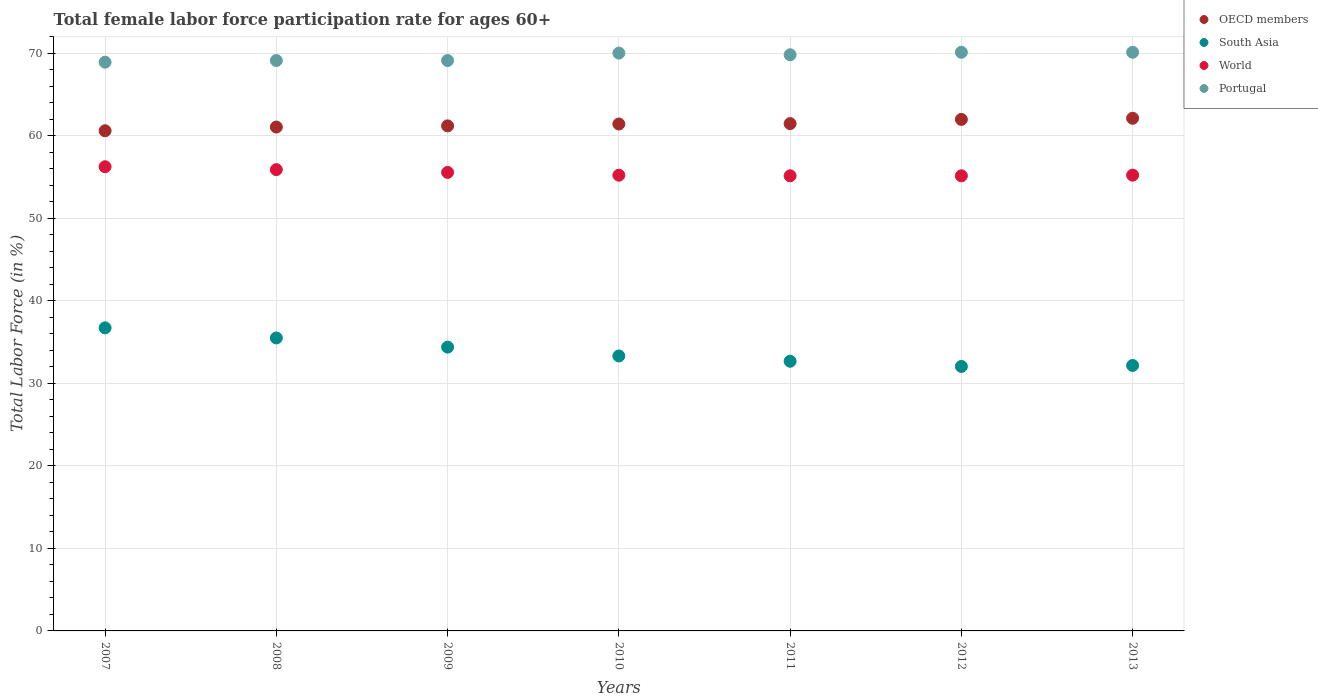Is the number of dotlines equal to the number of legend labels?
Your answer should be compact. Yes. What is the female labor force participation rate in World in 2009?
Provide a short and direct response. 55.55. Across all years, what is the maximum female labor force participation rate in South Asia?
Provide a short and direct response. 36.72. Across all years, what is the minimum female labor force participation rate in OECD members?
Ensure brevity in your answer.  60.59. In which year was the female labor force participation rate in Portugal minimum?
Offer a very short reply. 2007. What is the total female labor force participation rate in Portugal in the graph?
Keep it short and to the point. 487.1. What is the difference between the female labor force participation rate in Portugal in 2007 and that in 2011?
Provide a short and direct response. -0.9. What is the difference between the female labor force participation rate in World in 2010 and the female labor force participation rate in Portugal in 2012?
Make the answer very short. -14.89. What is the average female labor force participation rate in World per year?
Provide a short and direct response. 55.48. In the year 2008, what is the difference between the female labor force participation rate in World and female labor force participation rate in OECD members?
Provide a succinct answer. -5.16. What is the ratio of the female labor force participation rate in Portugal in 2007 to that in 2011?
Provide a succinct answer. 0.99. Is the difference between the female labor force participation rate in World in 2008 and 2012 greater than the difference between the female labor force participation rate in OECD members in 2008 and 2012?
Provide a short and direct response. Yes. What is the difference between the highest and the second highest female labor force participation rate in OECD members?
Your answer should be very brief. 0.14. What is the difference between the highest and the lowest female labor force participation rate in World?
Your response must be concise. 1.1. In how many years, is the female labor force participation rate in World greater than the average female labor force participation rate in World taken over all years?
Give a very brief answer. 3. Is it the case that in every year, the sum of the female labor force participation rate in South Asia and female labor force participation rate in OECD members  is greater than the sum of female labor force participation rate in Portugal and female labor force participation rate in World?
Provide a short and direct response. No. Does the female labor force participation rate in Portugal monotonically increase over the years?
Provide a succinct answer. No. Is the female labor force participation rate in Portugal strictly less than the female labor force participation rate in South Asia over the years?
Offer a terse response. No. How many dotlines are there?
Your response must be concise. 4. What is the difference between two consecutive major ticks on the Y-axis?
Provide a succinct answer. 10. Are the values on the major ticks of Y-axis written in scientific E-notation?
Make the answer very short. No. Does the graph contain any zero values?
Your answer should be compact. No. How are the legend labels stacked?
Provide a succinct answer. Vertical. What is the title of the graph?
Give a very brief answer. Total female labor force participation rate for ages 60+. Does "Armenia" appear as one of the legend labels in the graph?
Make the answer very short. No. What is the label or title of the Y-axis?
Provide a short and direct response. Total Labor Force (in %). What is the Total Labor Force (in %) in OECD members in 2007?
Make the answer very short. 60.59. What is the Total Labor Force (in %) of South Asia in 2007?
Offer a very short reply. 36.72. What is the Total Labor Force (in %) in World in 2007?
Ensure brevity in your answer.  56.23. What is the Total Labor Force (in %) of Portugal in 2007?
Keep it short and to the point. 68.9. What is the Total Labor Force (in %) of OECD members in 2008?
Your response must be concise. 61.04. What is the Total Labor Force (in %) in South Asia in 2008?
Keep it short and to the point. 35.49. What is the Total Labor Force (in %) of World in 2008?
Your answer should be very brief. 55.88. What is the Total Labor Force (in %) in Portugal in 2008?
Ensure brevity in your answer.  69.1. What is the Total Labor Force (in %) in OECD members in 2009?
Offer a terse response. 61.18. What is the Total Labor Force (in %) in South Asia in 2009?
Provide a succinct answer. 34.38. What is the Total Labor Force (in %) of World in 2009?
Make the answer very short. 55.55. What is the Total Labor Force (in %) in Portugal in 2009?
Your answer should be compact. 69.1. What is the Total Labor Force (in %) in OECD members in 2010?
Make the answer very short. 61.41. What is the Total Labor Force (in %) of South Asia in 2010?
Your response must be concise. 33.31. What is the Total Labor Force (in %) of World in 2010?
Provide a short and direct response. 55.21. What is the Total Labor Force (in %) of Portugal in 2010?
Your answer should be very brief. 70. What is the Total Labor Force (in %) of OECD members in 2011?
Make the answer very short. 61.46. What is the Total Labor Force (in %) of South Asia in 2011?
Keep it short and to the point. 32.67. What is the Total Labor Force (in %) in World in 2011?
Provide a succinct answer. 55.14. What is the Total Labor Force (in %) of Portugal in 2011?
Ensure brevity in your answer.  69.8. What is the Total Labor Force (in %) of OECD members in 2012?
Ensure brevity in your answer.  61.97. What is the Total Labor Force (in %) of South Asia in 2012?
Keep it short and to the point. 32.04. What is the Total Labor Force (in %) of World in 2012?
Provide a succinct answer. 55.14. What is the Total Labor Force (in %) in Portugal in 2012?
Your answer should be very brief. 70.1. What is the Total Labor Force (in %) of OECD members in 2013?
Your answer should be compact. 62.11. What is the Total Labor Force (in %) in South Asia in 2013?
Ensure brevity in your answer.  32.16. What is the Total Labor Force (in %) in World in 2013?
Your response must be concise. 55.21. What is the Total Labor Force (in %) of Portugal in 2013?
Give a very brief answer. 70.1. Across all years, what is the maximum Total Labor Force (in %) of OECD members?
Provide a short and direct response. 62.11. Across all years, what is the maximum Total Labor Force (in %) of South Asia?
Give a very brief answer. 36.72. Across all years, what is the maximum Total Labor Force (in %) in World?
Provide a succinct answer. 56.23. Across all years, what is the maximum Total Labor Force (in %) of Portugal?
Give a very brief answer. 70.1. Across all years, what is the minimum Total Labor Force (in %) of OECD members?
Ensure brevity in your answer.  60.59. Across all years, what is the minimum Total Labor Force (in %) in South Asia?
Offer a terse response. 32.04. Across all years, what is the minimum Total Labor Force (in %) of World?
Ensure brevity in your answer.  55.14. Across all years, what is the minimum Total Labor Force (in %) of Portugal?
Your response must be concise. 68.9. What is the total Total Labor Force (in %) of OECD members in the graph?
Ensure brevity in your answer.  429.76. What is the total Total Labor Force (in %) of South Asia in the graph?
Your answer should be very brief. 236.77. What is the total Total Labor Force (in %) of World in the graph?
Make the answer very short. 388.36. What is the total Total Labor Force (in %) of Portugal in the graph?
Your response must be concise. 487.1. What is the difference between the Total Labor Force (in %) of OECD members in 2007 and that in 2008?
Offer a very short reply. -0.45. What is the difference between the Total Labor Force (in %) in South Asia in 2007 and that in 2008?
Ensure brevity in your answer.  1.22. What is the difference between the Total Labor Force (in %) of World in 2007 and that in 2008?
Your response must be concise. 0.35. What is the difference between the Total Labor Force (in %) in OECD members in 2007 and that in 2009?
Keep it short and to the point. -0.59. What is the difference between the Total Labor Force (in %) of South Asia in 2007 and that in 2009?
Provide a short and direct response. 2.33. What is the difference between the Total Labor Force (in %) in World in 2007 and that in 2009?
Provide a succinct answer. 0.69. What is the difference between the Total Labor Force (in %) in OECD members in 2007 and that in 2010?
Your response must be concise. -0.82. What is the difference between the Total Labor Force (in %) in South Asia in 2007 and that in 2010?
Provide a short and direct response. 3.41. What is the difference between the Total Labor Force (in %) in World in 2007 and that in 2010?
Keep it short and to the point. 1.02. What is the difference between the Total Labor Force (in %) in Portugal in 2007 and that in 2010?
Give a very brief answer. -1.1. What is the difference between the Total Labor Force (in %) in OECD members in 2007 and that in 2011?
Ensure brevity in your answer.  -0.87. What is the difference between the Total Labor Force (in %) of South Asia in 2007 and that in 2011?
Give a very brief answer. 4.04. What is the difference between the Total Labor Force (in %) of World in 2007 and that in 2011?
Give a very brief answer. 1.1. What is the difference between the Total Labor Force (in %) in OECD members in 2007 and that in 2012?
Provide a short and direct response. -1.38. What is the difference between the Total Labor Force (in %) in South Asia in 2007 and that in 2012?
Your answer should be compact. 4.67. What is the difference between the Total Labor Force (in %) of World in 2007 and that in 2012?
Provide a succinct answer. 1.1. What is the difference between the Total Labor Force (in %) in OECD members in 2007 and that in 2013?
Your response must be concise. -1.51. What is the difference between the Total Labor Force (in %) in South Asia in 2007 and that in 2013?
Provide a short and direct response. 4.56. What is the difference between the Total Labor Force (in %) of World in 2007 and that in 2013?
Give a very brief answer. 1.02. What is the difference between the Total Labor Force (in %) in Portugal in 2007 and that in 2013?
Give a very brief answer. -1.2. What is the difference between the Total Labor Force (in %) in OECD members in 2008 and that in 2009?
Keep it short and to the point. -0.14. What is the difference between the Total Labor Force (in %) in South Asia in 2008 and that in 2009?
Keep it short and to the point. 1.11. What is the difference between the Total Labor Force (in %) in World in 2008 and that in 2009?
Ensure brevity in your answer.  0.34. What is the difference between the Total Labor Force (in %) in OECD members in 2008 and that in 2010?
Keep it short and to the point. -0.37. What is the difference between the Total Labor Force (in %) of South Asia in 2008 and that in 2010?
Provide a short and direct response. 2.18. What is the difference between the Total Labor Force (in %) in World in 2008 and that in 2010?
Offer a terse response. 0.67. What is the difference between the Total Labor Force (in %) of Portugal in 2008 and that in 2010?
Offer a terse response. -0.9. What is the difference between the Total Labor Force (in %) in OECD members in 2008 and that in 2011?
Your response must be concise. -0.42. What is the difference between the Total Labor Force (in %) in South Asia in 2008 and that in 2011?
Provide a succinct answer. 2.82. What is the difference between the Total Labor Force (in %) of World in 2008 and that in 2011?
Provide a short and direct response. 0.75. What is the difference between the Total Labor Force (in %) of OECD members in 2008 and that in 2012?
Give a very brief answer. -0.93. What is the difference between the Total Labor Force (in %) in South Asia in 2008 and that in 2012?
Provide a succinct answer. 3.45. What is the difference between the Total Labor Force (in %) in World in 2008 and that in 2012?
Your response must be concise. 0.75. What is the difference between the Total Labor Force (in %) in OECD members in 2008 and that in 2013?
Give a very brief answer. -1.06. What is the difference between the Total Labor Force (in %) of South Asia in 2008 and that in 2013?
Keep it short and to the point. 3.33. What is the difference between the Total Labor Force (in %) in World in 2008 and that in 2013?
Keep it short and to the point. 0.67. What is the difference between the Total Labor Force (in %) of OECD members in 2009 and that in 2010?
Provide a short and direct response. -0.23. What is the difference between the Total Labor Force (in %) in South Asia in 2009 and that in 2010?
Offer a very short reply. 1.07. What is the difference between the Total Labor Force (in %) of World in 2009 and that in 2010?
Ensure brevity in your answer.  0.34. What is the difference between the Total Labor Force (in %) in OECD members in 2009 and that in 2011?
Offer a very short reply. -0.27. What is the difference between the Total Labor Force (in %) of South Asia in 2009 and that in 2011?
Offer a terse response. 1.71. What is the difference between the Total Labor Force (in %) in World in 2009 and that in 2011?
Provide a succinct answer. 0.41. What is the difference between the Total Labor Force (in %) of Portugal in 2009 and that in 2011?
Offer a very short reply. -0.7. What is the difference between the Total Labor Force (in %) in OECD members in 2009 and that in 2012?
Your answer should be very brief. -0.78. What is the difference between the Total Labor Force (in %) of South Asia in 2009 and that in 2012?
Provide a succinct answer. 2.34. What is the difference between the Total Labor Force (in %) of World in 2009 and that in 2012?
Make the answer very short. 0.41. What is the difference between the Total Labor Force (in %) in Portugal in 2009 and that in 2012?
Offer a very short reply. -1. What is the difference between the Total Labor Force (in %) in OECD members in 2009 and that in 2013?
Your answer should be compact. -0.92. What is the difference between the Total Labor Force (in %) in South Asia in 2009 and that in 2013?
Make the answer very short. 2.22. What is the difference between the Total Labor Force (in %) of World in 2009 and that in 2013?
Offer a very short reply. 0.33. What is the difference between the Total Labor Force (in %) of Portugal in 2009 and that in 2013?
Ensure brevity in your answer.  -1. What is the difference between the Total Labor Force (in %) of OECD members in 2010 and that in 2011?
Your answer should be very brief. -0.05. What is the difference between the Total Labor Force (in %) in South Asia in 2010 and that in 2011?
Make the answer very short. 0.64. What is the difference between the Total Labor Force (in %) of World in 2010 and that in 2011?
Provide a short and direct response. 0.07. What is the difference between the Total Labor Force (in %) of Portugal in 2010 and that in 2011?
Keep it short and to the point. 0.2. What is the difference between the Total Labor Force (in %) of OECD members in 2010 and that in 2012?
Your answer should be very brief. -0.56. What is the difference between the Total Labor Force (in %) of South Asia in 2010 and that in 2012?
Your response must be concise. 1.27. What is the difference between the Total Labor Force (in %) of World in 2010 and that in 2012?
Offer a terse response. 0.07. What is the difference between the Total Labor Force (in %) in OECD members in 2010 and that in 2013?
Make the answer very short. -0.7. What is the difference between the Total Labor Force (in %) in South Asia in 2010 and that in 2013?
Give a very brief answer. 1.15. What is the difference between the Total Labor Force (in %) in World in 2010 and that in 2013?
Give a very brief answer. -0. What is the difference between the Total Labor Force (in %) of Portugal in 2010 and that in 2013?
Make the answer very short. -0.1. What is the difference between the Total Labor Force (in %) in OECD members in 2011 and that in 2012?
Make the answer very short. -0.51. What is the difference between the Total Labor Force (in %) of South Asia in 2011 and that in 2012?
Provide a succinct answer. 0.63. What is the difference between the Total Labor Force (in %) of World in 2011 and that in 2012?
Give a very brief answer. 0. What is the difference between the Total Labor Force (in %) in OECD members in 2011 and that in 2013?
Offer a terse response. -0.65. What is the difference between the Total Labor Force (in %) of South Asia in 2011 and that in 2013?
Make the answer very short. 0.51. What is the difference between the Total Labor Force (in %) in World in 2011 and that in 2013?
Offer a very short reply. -0.08. What is the difference between the Total Labor Force (in %) of OECD members in 2012 and that in 2013?
Offer a very short reply. -0.14. What is the difference between the Total Labor Force (in %) in South Asia in 2012 and that in 2013?
Your answer should be very brief. -0.12. What is the difference between the Total Labor Force (in %) of World in 2012 and that in 2013?
Provide a succinct answer. -0.08. What is the difference between the Total Labor Force (in %) of Portugal in 2012 and that in 2013?
Keep it short and to the point. 0. What is the difference between the Total Labor Force (in %) in OECD members in 2007 and the Total Labor Force (in %) in South Asia in 2008?
Your answer should be very brief. 25.1. What is the difference between the Total Labor Force (in %) of OECD members in 2007 and the Total Labor Force (in %) of World in 2008?
Your answer should be very brief. 4.71. What is the difference between the Total Labor Force (in %) of OECD members in 2007 and the Total Labor Force (in %) of Portugal in 2008?
Provide a succinct answer. -8.51. What is the difference between the Total Labor Force (in %) of South Asia in 2007 and the Total Labor Force (in %) of World in 2008?
Keep it short and to the point. -19.17. What is the difference between the Total Labor Force (in %) of South Asia in 2007 and the Total Labor Force (in %) of Portugal in 2008?
Offer a terse response. -32.38. What is the difference between the Total Labor Force (in %) of World in 2007 and the Total Labor Force (in %) of Portugal in 2008?
Ensure brevity in your answer.  -12.87. What is the difference between the Total Labor Force (in %) of OECD members in 2007 and the Total Labor Force (in %) of South Asia in 2009?
Keep it short and to the point. 26.21. What is the difference between the Total Labor Force (in %) in OECD members in 2007 and the Total Labor Force (in %) in World in 2009?
Offer a terse response. 5.05. What is the difference between the Total Labor Force (in %) of OECD members in 2007 and the Total Labor Force (in %) of Portugal in 2009?
Ensure brevity in your answer.  -8.51. What is the difference between the Total Labor Force (in %) of South Asia in 2007 and the Total Labor Force (in %) of World in 2009?
Provide a succinct answer. -18.83. What is the difference between the Total Labor Force (in %) in South Asia in 2007 and the Total Labor Force (in %) in Portugal in 2009?
Your answer should be very brief. -32.38. What is the difference between the Total Labor Force (in %) in World in 2007 and the Total Labor Force (in %) in Portugal in 2009?
Your response must be concise. -12.87. What is the difference between the Total Labor Force (in %) of OECD members in 2007 and the Total Labor Force (in %) of South Asia in 2010?
Keep it short and to the point. 27.28. What is the difference between the Total Labor Force (in %) in OECD members in 2007 and the Total Labor Force (in %) in World in 2010?
Provide a short and direct response. 5.38. What is the difference between the Total Labor Force (in %) of OECD members in 2007 and the Total Labor Force (in %) of Portugal in 2010?
Provide a succinct answer. -9.41. What is the difference between the Total Labor Force (in %) in South Asia in 2007 and the Total Labor Force (in %) in World in 2010?
Offer a terse response. -18.49. What is the difference between the Total Labor Force (in %) of South Asia in 2007 and the Total Labor Force (in %) of Portugal in 2010?
Offer a very short reply. -33.28. What is the difference between the Total Labor Force (in %) of World in 2007 and the Total Labor Force (in %) of Portugal in 2010?
Provide a succinct answer. -13.77. What is the difference between the Total Labor Force (in %) of OECD members in 2007 and the Total Labor Force (in %) of South Asia in 2011?
Offer a terse response. 27.92. What is the difference between the Total Labor Force (in %) of OECD members in 2007 and the Total Labor Force (in %) of World in 2011?
Your answer should be very brief. 5.46. What is the difference between the Total Labor Force (in %) of OECD members in 2007 and the Total Labor Force (in %) of Portugal in 2011?
Keep it short and to the point. -9.21. What is the difference between the Total Labor Force (in %) of South Asia in 2007 and the Total Labor Force (in %) of World in 2011?
Give a very brief answer. -18.42. What is the difference between the Total Labor Force (in %) of South Asia in 2007 and the Total Labor Force (in %) of Portugal in 2011?
Your answer should be very brief. -33.08. What is the difference between the Total Labor Force (in %) of World in 2007 and the Total Labor Force (in %) of Portugal in 2011?
Keep it short and to the point. -13.57. What is the difference between the Total Labor Force (in %) of OECD members in 2007 and the Total Labor Force (in %) of South Asia in 2012?
Provide a succinct answer. 28.55. What is the difference between the Total Labor Force (in %) of OECD members in 2007 and the Total Labor Force (in %) of World in 2012?
Ensure brevity in your answer.  5.46. What is the difference between the Total Labor Force (in %) of OECD members in 2007 and the Total Labor Force (in %) of Portugal in 2012?
Make the answer very short. -9.51. What is the difference between the Total Labor Force (in %) of South Asia in 2007 and the Total Labor Force (in %) of World in 2012?
Your response must be concise. -18.42. What is the difference between the Total Labor Force (in %) of South Asia in 2007 and the Total Labor Force (in %) of Portugal in 2012?
Your answer should be compact. -33.38. What is the difference between the Total Labor Force (in %) of World in 2007 and the Total Labor Force (in %) of Portugal in 2012?
Give a very brief answer. -13.87. What is the difference between the Total Labor Force (in %) in OECD members in 2007 and the Total Labor Force (in %) in South Asia in 2013?
Your response must be concise. 28.43. What is the difference between the Total Labor Force (in %) of OECD members in 2007 and the Total Labor Force (in %) of World in 2013?
Provide a succinct answer. 5.38. What is the difference between the Total Labor Force (in %) of OECD members in 2007 and the Total Labor Force (in %) of Portugal in 2013?
Make the answer very short. -9.51. What is the difference between the Total Labor Force (in %) of South Asia in 2007 and the Total Labor Force (in %) of World in 2013?
Your answer should be very brief. -18.5. What is the difference between the Total Labor Force (in %) in South Asia in 2007 and the Total Labor Force (in %) in Portugal in 2013?
Provide a succinct answer. -33.38. What is the difference between the Total Labor Force (in %) in World in 2007 and the Total Labor Force (in %) in Portugal in 2013?
Give a very brief answer. -13.87. What is the difference between the Total Labor Force (in %) in OECD members in 2008 and the Total Labor Force (in %) in South Asia in 2009?
Provide a short and direct response. 26.66. What is the difference between the Total Labor Force (in %) in OECD members in 2008 and the Total Labor Force (in %) in World in 2009?
Provide a succinct answer. 5.49. What is the difference between the Total Labor Force (in %) in OECD members in 2008 and the Total Labor Force (in %) in Portugal in 2009?
Make the answer very short. -8.06. What is the difference between the Total Labor Force (in %) of South Asia in 2008 and the Total Labor Force (in %) of World in 2009?
Your answer should be very brief. -20.06. What is the difference between the Total Labor Force (in %) of South Asia in 2008 and the Total Labor Force (in %) of Portugal in 2009?
Make the answer very short. -33.61. What is the difference between the Total Labor Force (in %) of World in 2008 and the Total Labor Force (in %) of Portugal in 2009?
Your response must be concise. -13.22. What is the difference between the Total Labor Force (in %) in OECD members in 2008 and the Total Labor Force (in %) in South Asia in 2010?
Keep it short and to the point. 27.73. What is the difference between the Total Labor Force (in %) of OECD members in 2008 and the Total Labor Force (in %) of World in 2010?
Keep it short and to the point. 5.83. What is the difference between the Total Labor Force (in %) of OECD members in 2008 and the Total Labor Force (in %) of Portugal in 2010?
Offer a terse response. -8.96. What is the difference between the Total Labor Force (in %) of South Asia in 2008 and the Total Labor Force (in %) of World in 2010?
Provide a succinct answer. -19.72. What is the difference between the Total Labor Force (in %) of South Asia in 2008 and the Total Labor Force (in %) of Portugal in 2010?
Provide a short and direct response. -34.51. What is the difference between the Total Labor Force (in %) in World in 2008 and the Total Labor Force (in %) in Portugal in 2010?
Ensure brevity in your answer.  -14.12. What is the difference between the Total Labor Force (in %) of OECD members in 2008 and the Total Labor Force (in %) of South Asia in 2011?
Offer a terse response. 28.37. What is the difference between the Total Labor Force (in %) of OECD members in 2008 and the Total Labor Force (in %) of World in 2011?
Your response must be concise. 5.91. What is the difference between the Total Labor Force (in %) of OECD members in 2008 and the Total Labor Force (in %) of Portugal in 2011?
Keep it short and to the point. -8.76. What is the difference between the Total Labor Force (in %) in South Asia in 2008 and the Total Labor Force (in %) in World in 2011?
Give a very brief answer. -19.64. What is the difference between the Total Labor Force (in %) in South Asia in 2008 and the Total Labor Force (in %) in Portugal in 2011?
Give a very brief answer. -34.31. What is the difference between the Total Labor Force (in %) of World in 2008 and the Total Labor Force (in %) of Portugal in 2011?
Provide a short and direct response. -13.92. What is the difference between the Total Labor Force (in %) in OECD members in 2008 and the Total Labor Force (in %) in South Asia in 2012?
Your answer should be compact. 29. What is the difference between the Total Labor Force (in %) of OECD members in 2008 and the Total Labor Force (in %) of World in 2012?
Keep it short and to the point. 5.91. What is the difference between the Total Labor Force (in %) in OECD members in 2008 and the Total Labor Force (in %) in Portugal in 2012?
Make the answer very short. -9.06. What is the difference between the Total Labor Force (in %) in South Asia in 2008 and the Total Labor Force (in %) in World in 2012?
Your answer should be very brief. -19.64. What is the difference between the Total Labor Force (in %) of South Asia in 2008 and the Total Labor Force (in %) of Portugal in 2012?
Offer a terse response. -34.61. What is the difference between the Total Labor Force (in %) of World in 2008 and the Total Labor Force (in %) of Portugal in 2012?
Offer a terse response. -14.22. What is the difference between the Total Labor Force (in %) in OECD members in 2008 and the Total Labor Force (in %) in South Asia in 2013?
Keep it short and to the point. 28.88. What is the difference between the Total Labor Force (in %) in OECD members in 2008 and the Total Labor Force (in %) in World in 2013?
Your response must be concise. 5.83. What is the difference between the Total Labor Force (in %) of OECD members in 2008 and the Total Labor Force (in %) of Portugal in 2013?
Ensure brevity in your answer.  -9.06. What is the difference between the Total Labor Force (in %) of South Asia in 2008 and the Total Labor Force (in %) of World in 2013?
Give a very brief answer. -19.72. What is the difference between the Total Labor Force (in %) in South Asia in 2008 and the Total Labor Force (in %) in Portugal in 2013?
Provide a short and direct response. -34.61. What is the difference between the Total Labor Force (in %) of World in 2008 and the Total Labor Force (in %) of Portugal in 2013?
Offer a terse response. -14.22. What is the difference between the Total Labor Force (in %) of OECD members in 2009 and the Total Labor Force (in %) of South Asia in 2010?
Provide a short and direct response. 27.87. What is the difference between the Total Labor Force (in %) of OECD members in 2009 and the Total Labor Force (in %) of World in 2010?
Provide a succinct answer. 5.97. What is the difference between the Total Labor Force (in %) of OECD members in 2009 and the Total Labor Force (in %) of Portugal in 2010?
Give a very brief answer. -8.82. What is the difference between the Total Labor Force (in %) of South Asia in 2009 and the Total Labor Force (in %) of World in 2010?
Your answer should be compact. -20.83. What is the difference between the Total Labor Force (in %) in South Asia in 2009 and the Total Labor Force (in %) in Portugal in 2010?
Keep it short and to the point. -35.62. What is the difference between the Total Labor Force (in %) in World in 2009 and the Total Labor Force (in %) in Portugal in 2010?
Give a very brief answer. -14.45. What is the difference between the Total Labor Force (in %) in OECD members in 2009 and the Total Labor Force (in %) in South Asia in 2011?
Offer a terse response. 28.51. What is the difference between the Total Labor Force (in %) of OECD members in 2009 and the Total Labor Force (in %) of World in 2011?
Your response must be concise. 6.05. What is the difference between the Total Labor Force (in %) of OECD members in 2009 and the Total Labor Force (in %) of Portugal in 2011?
Ensure brevity in your answer.  -8.62. What is the difference between the Total Labor Force (in %) in South Asia in 2009 and the Total Labor Force (in %) in World in 2011?
Offer a terse response. -20.75. What is the difference between the Total Labor Force (in %) of South Asia in 2009 and the Total Labor Force (in %) of Portugal in 2011?
Keep it short and to the point. -35.42. What is the difference between the Total Labor Force (in %) of World in 2009 and the Total Labor Force (in %) of Portugal in 2011?
Provide a succinct answer. -14.25. What is the difference between the Total Labor Force (in %) of OECD members in 2009 and the Total Labor Force (in %) of South Asia in 2012?
Offer a terse response. 29.14. What is the difference between the Total Labor Force (in %) of OECD members in 2009 and the Total Labor Force (in %) of World in 2012?
Offer a very short reply. 6.05. What is the difference between the Total Labor Force (in %) in OECD members in 2009 and the Total Labor Force (in %) in Portugal in 2012?
Offer a terse response. -8.92. What is the difference between the Total Labor Force (in %) of South Asia in 2009 and the Total Labor Force (in %) of World in 2012?
Ensure brevity in your answer.  -20.75. What is the difference between the Total Labor Force (in %) of South Asia in 2009 and the Total Labor Force (in %) of Portugal in 2012?
Provide a short and direct response. -35.72. What is the difference between the Total Labor Force (in %) of World in 2009 and the Total Labor Force (in %) of Portugal in 2012?
Your response must be concise. -14.55. What is the difference between the Total Labor Force (in %) of OECD members in 2009 and the Total Labor Force (in %) of South Asia in 2013?
Offer a terse response. 29.02. What is the difference between the Total Labor Force (in %) of OECD members in 2009 and the Total Labor Force (in %) of World in 2013?
Give a very brief answer. 5.97. What is the difference between the Total Labor Force (in %) in OECD members in 2009 and the Total Labor Force (in %) in Portugal in 2013?
Your response must be concise. -8.92. What is the difference between the Total Labor Force (in %) in South Asia in 2009 and the Total Labor Force (in %) in World in 2013?
Provide a short and direct response. -20.83. What is the difference between the Total Labor Force (in %) in South Asia in 2009 and the Total Labor Force (in %) in Portugal in 2013?
Provide a short and direct response. -35.72. What is the difference between the Total Labor Force (in %) in World in 2009 and the Total Labor Force (in %) in Portugal in 2013?
Offer a terse response. -14.55. What is the difference between the Total Labor Force (in %) of OECD members in 2010 and the Total Labor Force (in %) of South Asia in 2011?
Provide a succinct answer. 28.74. What is the difference between the Total Labor Force (in %) in OECD members in 2010 and the Total Labor Force (in %) in World in 2011?
Your answer should be very brief. 6.27. What is the difference between the Total Labor Force (in %) in OECD members in 2010 and the Total Labor Force (in %) in Portugal in 2011?
Offer a very short reply. -8.39. What is the difference between the Total Labor Force (in %) of South Asia in 2010 and the Total Labor Force (in %) of World in 2011?
Offer a very short reply. -21.83. What is the difference between the Total Labor Force (in %) in South Asia in 2010 and the Total Labor Force (in %) in Portugal in 2011?
Your response must be concise. -36.49. What is the difference between the Total Labor Force (in %) in World in 2010 and the Total Labor Force (in %) in Portugal in 2011?
Offer a terse response. -14.59. What is the difference between the Total Labor Force (in %) of OECD members in 2010 and the Total Labor Force (in %) of South Asia in 2012?
Keep it short and to the point. 29.37. What is the difference between the Total Labor Force (in %) of OECD members in 2010 and the Total Labor Force (in %) of World in 2012?
Provide a succinct answer. 6.28. What is the difference between the Total Labor Force (in %) in OECD members in 2010 and the Total Labor Force (in %) in Portugal in 2012?
Provide a short and direct response. -8.69. What is the difference between the Total Labor Force (in %) of South Asia in 2010 and the Total Labor Force (in %) of World in 2012?
Give a very brief answer. -21.83. What is the difference between the Total Labor Force (in %) in South Asia in 2010 and the Total Labor Force (in %) in Portugal in 2012?
Offer a very short reply. -36.79. What is the difference between the Total Labor Force (in %) in World in 2010 and the Total Labor Force (in %) in Portugal in 2012?
Make the answer very short. -14.89. What is the difference between the Total Labor Force (in %) of OECD members in 2010 and the Total Labor Force (in %) of South Asia in 2013?
Make the answer very short. 29.25. What is the difference between the Total Labor Force (in %) in OECD members in 2010 and the Total Labor Force (in %) in World in 2013?
Keep it short and to the point. 6.2. What is the difference between the Total Labor Force (in %) in OECD members in 2010 and the Total Labor Force (in %) in Portugal in 2013?
Give a very brief answer. -8.69. What is the difference between the Total Labor Force (in %) in South Asia in 2010 and the Total Labor Force (in %) in World in 2013?
Offer a terse response. -21.91. What is the difference between the Total Labor Force (in %) of South Asia in 2010 and the Total Labor Force (in %) of Portugal in 2013?
Your answer should be compact. -36.79. What is the difference between the Total Labor Force (in %) of World in 2010 and the Total Labor Force (in %) of Portugal in 2013?
Your answer should be compact. -14.89. What is the difference between the Total Labor Force (in %) in OECD members in 2011 and the Total Labor Force (in %) in South Asia in 2012?
Make the answer very short. 29.42. What is the difference between the Total Labor Force (in %) in OECD members in 2011 and the Total Labor Force (in %) in World in 2012?
Make the answer very short. 6.32. What is the difference between the Total Labor Force (in %) of OECD members in 2011 and the Total Labor Force (in %) of Portugal in 2012?
Offer a very short reply. -8.64. What is the difference between the Total Labor Force (in %) of South Asia in 2011 and the Total Labor Force (in %) of World in 2012?
Make the answer very short. -22.46. What is the difference between the Total Labor Force (in %) in South Asia in 2011 and the Total Labor Force (in %) in Portugal in 2012?
Ensure brevity in your answer.  -37.43. What is the difference between the Total Labor Force (in %) in World in 2011 and the Total Labor Force (in %) in Portugal in 2012?
Your response must be concise. -14.96. What is the difference between the Total Labor Force (in %) of OECD members in 2011 and the Total Labor Force (in %) of South Asia in 2013?
Make the answer very short. 29.3. What is the difference between the Total Labor Force (in %) in OECD members in 2011 and the Total Labor Force (in %) in World in 2013?
Offer a very short reply. 6.24. What is the difference between the Total Labor Force (in %) of OECD members in 2011 and the Total Labor Force (in %) of Portugal in 2013?
Give a very brief answer. -8.64. What is the difference between the Total Labor Force (in %) in South Asia in 2011 and the Total Labor Force (in %) in World in 2013?
Make the answer very short. -22.54. What is the difference between the Total Labor Force (in %) in South Asia in 2011 and the Total Labor Force (in %) in Portugal in 2013?
Keep it short and to the point. -37.43. What is the difference between the Total Labor Force (in %) of World in 2011 and the Total Labor Force (in %) of Portugal in 2013?
Offer a terse response. -14.96. What is the difference between the Total Labor Force (in %) of OECD members in 2012 and the Total Labor Force (in %) of South Asia in 2013?
Offer a very short reply. 29.81. What is the difference between the Total Labor Force (in %) of OECD members in 2012 and the Total Labor Force (in %) of World in 2013?
Ensure brevity in your answer.  6.75. What is the difference between the Total Labor Force (in %) of OECD members in 2012 and the Total Labor Force (in %) of Portugal in 2013?
Offer a terse response. -8.13. What is the difference between the Total Labor Force (in %) of South Asia in 2012 and the Total Labor Force (in %) of World in 2013?
Give a very brief answer. -23.17. What is the difference between the Total Labor Force (in %) of South Asia in 2012 and the Total Labor Force (in %) of Portugal in 2013?
Your response must be concise. -38.06. What is the difference between the Total Labor Force (in %) of World in 2012 and the Total Labor Force (in %) of Portugal in 2013?
Provide a short and direct response. -14.96. What is the average Total Labor Force (in %) in OECD members per year?
Ensure brevity in your answer.  61.39. What is the average Total Labor Force (in %) of South Asia per year?
Ensure brevity in your answer.  33.82. What is the average Total Labor Force (in %) of World per year?
Make the answer very short. 55.48. What is the average Total Labor Force (in %) in Portugal per year?
Offer a very short reply. 69.59. In the year 2007, what is the difference between the Total Labor Force (in %) of OECD members and Total Labor Force (in %) of South Asia?
Give a very brief answer. 23.88. In the year 2007, what is the difference between the Total Labor Force (in %) of OECD members and Total Labor Force (in %) of World?
Give a very brief answer. 4.36. In the year 2007, what is the difference between the Total Labor Force (in %) of OECD members and Total Labor Force (in %) of Portugal?
Give a very brief answer. -8.31. In the year 2007, what is the difference between the Total Labor Force (in %) of South Asia and Total Labor Force (in %) of World?
Offer a terse response. -19.52. In the year 2007, what is the difference between the Total Labor Force (in %) of South Asia and Total Labor Force (in %) of Portugal?
Make the answer very short. -32.18. In the year 2007, what is the difference between the Total Labor Force (in %) in World and Total Labor Force (in %) in Portugal?
Offer a very short reply. -12.67. In the year 2008, what is the difference between the Total Labor Force (in %) of OECD members and Total Labor Force (in %) of South Asia?
Give a very brief answer. 25.55. In the year 2008, what is the difference between the Total Labor Force (in %) in OECD members and Total Labor Force (in %) in World?
Ensure brevity in your answer.  5.16. In the year 2008, what is the difference between the Total Labor Force (in %) of OECD members and Total Labor Force (in %) of Portugal?
Offer a terse response. -8.06. In the year 2008, what is the difference between the Total Labor Force (in %) in South Asia and Total Labor Force (in %) in World?
Your answer should be very brief. -20.39. In the year 2008, what is the difference between the Total Labor Force (in %) of South Asia and Total Labor Force (in %) of Portugal?
Offer a terse response. -33.61. In the year 2008, what is the difference between the Total Labor Force (in %) in World and Total Labor Force (in %) in Portugal?
Offer a terse response. -13.22. In the year 2009, what is the difference between the Total Labor Force (in %) of OECD members and Total Labor Force (in %) of South Asia?
Provide a short and direct response. 26.8. In the year 2009, what is the difference between the Total Labor Force (in %) of OECD members and Total Labor Force (in %) of World?
Give a very brief answer. 5.64. In the year 2009, what is the difference between the Total Labor Force (in %) in OECD members and Total Labor Force (in %) in Portugal?
Offer a terse response. -7.92. In the year 2009, what is the difference between the Total Labor Force (in %) of South Asia and Total Labor Force (in %) of World?
Your answer should be compact. -21.16. In the year 2009, what is the difference between the Total Labor Force (in %) in South Asia and Total Labor Force (in %) in Portugal?
Your response must be concise. -34.72. In the year 2009, what is the difference between the Total Labor Force (in %) of World and Total Labor Force (in %) of Portugal?
Provide a short and direct response. -13.55. In the year 2010, what is the difference between the Total Labor Force (in %) in OECD members and Total Labor Force (in %) in South Asia?
Ensure brevity in your answer.  28.1. In the year 2010, what is the difference between the Total Labor Force (in %) in OECD members and Total Labor Force (in %) in World?
Your answer should be compact. 6.2. In the year 2010, what is the difference between the Total Labor Force (in %) of OECD members and Total Labor Force (in %) of Portugal?
Your answer should be very brief. -8.59. In the year 2010, what is the difference between the Total Labor Force (in %) of South Asia and Total Labor Force (in %) of World?
Your response must be concise. -21.9. In the year 2010, what is the difference between the Total Labor Force (in %) of South Asia and Total Labor Force (in %) of Portugal?
Keep it short and to the point. -36.69. In the year 2010, what is the difference between the Total Labor Force (in %) in World and Total Labor Force (in %) in Portugal?
Provide a succinct answer. -14.79. In the year 2011, what is the difference between the Total Labor Force (in %) in OECD members and Total Labor Force (in %) in South Asia?
Give a very brief answer. 28.79. In the year 2011, what is the difference between the Total Labor Force (in %) in OECD members and Total Labor Force (in %) in World?
Make the answer very short. 6.32. In the year 2011, what is the difference between the Total Labor Force (in %) in OECD members and Total Labor Force (in %) in Portugal?
Your answer should be very brief. -8.34. In the year 2011, what is the difference between the Total Labor Force (in %) in South Asia and Total Labor Force (in %) in World?
Provide a short and direct response. -22.46. In the year 2011, what is the difference between the Total Labor Force (in %) of South Asia and Total Labor Force (in %) of Portugal?
Give a very brief answer. -37.13. In the year 2011, what is the difference between the Total Labor Force (in %) in World and Total Labor Force (in %) in Portugal?
Your response must be concise. -14.66. In the year 2012, what is the difference between the Total Labor Force (in %) of OECD members and Total Labor Force (in %) of South Asia?
Keep it short and to the point. 29.93. In the year 2012, what is the difference between the Total Labor Force (in %) of OECD members and Total Labor Force (in %) of World?
Your answer should be compact. 6.83. In the year 2012, what is the difference between the Total Labor Force (in %) of OECD members and Total Labor Force (in %) of Portugal?
Provide a succinct answer. -8.13. In the year 2012, what is the difference between the Total Labor Force (in %) in South Asia and Total Labor Force (in %) in World?
Offer a terse response. -23.09. In the year 2012, what is the difference between the Total Labor Force (in %) in South Asia and Total Labor Force (in %) in Portugal?
Provide a succinct answer. -38.06. In the year 2012, what is the difference between the Total Labor Force (in %) in World and Total Labor Force (in %) in Portugal?
Your response must be concise. -14.96. In the year 2013, what is the difference between the Total Labor Force (in %) in OECD members and Total Labor Force (in %) in South Asia?
Provide a short and direct response. 29.95. In the year 2013, what is the difference between the Total Labor Force (in %) of OECD members and Total Labor Force (in %) of World?
Your response must be concise. 6.89. In the year 2013, what is the difference between the Total Labor Force (in %) in OECD members and Total Labor Force (in %) in Portugal?
Offer a very short reply. -7.99. In the year 2013, what is the difference between the Total Labor Force (in %) in South Asia and Total Labor Force (in %) in World?
Keep it short and to the point. -23.05. In the year 2013, what is the difference between the Total Labor Force (in %) in South Asia and Total Labor Force (in %) in Portugal?
Offer a very short reply. -37.94. In the year 2013, what is the difference between the Total Labor Force (in %) in World and Total Labor Force (in %) in Portugal?
Offer a terse response. -14.89. What is the ratio of the Total Labor Force (in %) of South Asia in 2007 to that in 2008?
Offer a very short reply. 1.03. What is the ratio of the Total Labor Force (in %) of World in 2007 to that in 2008?
Provide a short and direct response. 1.01. What is the ratio of the Total Labor Force (in %) of Portugal in 2007 to that in 2008?
Offer a terse response. 1. What is the ratio of the Total Labor Force (in %) of OECD members in 2007 to that in 2009?
Offer a very short reply. 0.99. What is the ratio of the Total Labor Force (in %) of South Asia in 2007 to that in 2009?
Your answer should be very brief. 1.07. What is the ratio of the Total Labor Force (in %) in World in 2007 to that in 2009?
Your answer should be compact. 1.01. What is the ratio of the Total Labor Force (in %) of Portugal in 2007 to that in 2009?
Keep it short and to the point. 1. What is the ratio of the Total Labor Force (in %) in OECD members in 2007 to that in 2010?
Give a very brief answer. 0.99. What is the ratio of the Total Labor Force (in %) of South Asia in 2007 to that in 2010?
Your answer should be very brief. 1.1. What is the ratio of the Total Labor Force (in %) in World in 2007 to that in 2010?
Offer a terse response. 1.02. What is the ratio of the Total Labor Force (in %) of Portugal in 2007 to that in 2010?
Provide a succinct answer. 0.98. What is the ratio of the Total Labor Force (in %) of OECD members in 2007 to that in 2011?
Your response must be concise. 0.99. What is the ratio of the Total Labor Force (in %) in South Asia in 2007 to that in 2011?
Provide a short and direct response. 1.12. What is the ratio of the Total Labor Force (in %) of World in 2007 to that in 2011?
Offer a very short reply. 1.02. What is the ratio of the Total Labor Force (in %) of Portugal in 2007 to that in 2011?
Provide a succinct answer. 0.99. What is the ratio of the Total Labor Force (in %) in OECD members in 2007 to that in 2012?
Offer a very short reply. 0.98. What is the ratio of the Total Labor Force (in %) in South Asia in 2007 to that in 2012?
Make the answer very short. 1.15. What is the ratio of the Total Labor Force (in %) in World in 2007 to that in 2012?
Ensure brevity in your answer.  1.02. What is the ratio of the Total Labor Force (in %) of Portugal in 2007 to that in 2012?
Give a very brief answer. 0.98. What is the ratio of the Total Labor Force (in %) in OECD members in 2007 to that in 2013?
Your answer should be compact. 0.98. What is the ratio of the Total Labor Force (in %) of South Asia in 2007 to that in 2013?
Provide a succinct answer. 1.14. What is the ratio of the Total Labor Force (in %) in World in 2007 to that in 2013?
Provide a short and direct response. 1.02. What is the ratio of the Total Labor Force (in %) in Portugal in 2007 to that in 2013?
Ensure brevity in your answer.  0.98. What is the ratio of the Total Labor Force (in %) of OECD members in 2008 to that in 2009?
Keep it short and to the point. 1. What is the ratio of the Total Labor Force (in %) in South Asia in 2008 to that in 2009?
Give a very brief answer. 1.03. What is the ratio of the Total Labor Force (in %) of Portugal in 2008 to that in 2009?
Your answer should be very brief. 1. What is the ratio of the Total Labor Force (in %) of OECD members in 2008 to that in 2010?
Provide a succinct answer. 0.99. What is the ratio of the Total Labor Force (in %) of South Asia in 2008 to that in 2010?
Keep it short and to the point. 1.07. What is the ratio of the Total Labor Force (in %) in World in 2008 to that in 2010?
Your answer should be compact. 1.01. What is the ratio of the Total Labor Force (in %) in Portugal in 2008 to that in 2010?
Provide a short and direct response. 0.99. What is the ratio of the Total Labor Force (in %) in South Asia in 2008 to that in 2011?
Keep it short and to the point. 1.09. What is the ratio of the Total Labor Force (in %) in World in 2008 to that in 2011?
Provide a succinct answer. 1.01. What is the ratio of the Total Labor Force (in %) of OECD members in 2008 to that in 2012?
Offer a very short reply. 0.99. What is the ratio of the Total Labor Force (in %) of South Asia in 2008 to that in 2012?
Make the answer very short. 1.11. What is the ratio of the Total Labor Force (in %) in World in 2008 to that in 2012?
Give a very brief answer. 1.01. What is the ratio of the Total Labor Force (in %) in Portugal in 2008 to that in 2012?
Give a very brief answer. 0.99. What is the ratio of the Total Labor Force (in %) in OECD members in 2008 to that in 2013?
Provide a short and direct response. 0.98. What is the ratio of the Total Labor Force (in %) in South Asia in 2008 to that in 2013?
Your answer should be compact. 1.1. What is the ratio of the Total Labor Force (in %) in World in 2008 to that in 2013?
Your answer should be very brief. 1.01. What is the ratio of the Total Labor Force (in %) of Portugal in 2008 to that in 2013?
Provide a succinct answer. 0.99. What is the ratio of the Total Labor Force (in %) in OECD members in 2009 to that in 2010?
Provide a short and direct response. 1. What is the ratio of the Total Labor Force (in %) of South Asia in 2009 to that in 2010?
Offer a very short reply. 1.03. What is the ratio of the Total Labor Force (in %) in World in 2009 to that in 2010?
Offer a very short reply. 1.01. What is the ratio of the Total Labor Force (in %) of Portugal in 2009 to that in 2010?
Provide a succinct answer. 0.99. What is the ratio of the Total Labor Force (in %) of South Asia in 2009 to that in 2011?
Make the answer very short. 1.05. What is the ratio of the Total Labor Force (in %) in World in 2009 to that in 2011?
Offer a very short reply. 1.01. What is the ratio of the Total Labor Force (in %) of OECD members in 2009 to that in 2012?
Offer a very short reply. 0.99. What is the ratio of the Total Labor Force (in %) in South Asia in 2009 to that in 2012?
Provide a succinct answer. 1.07. What is the ratio of the Total Labor Force (in %) in World in 2009 to that in 2012?
Give a very brief answer. 1.01. What is the ratio of the Total Labor Force (in %) of Portugal in 2009 to that in 2012?
Offer a very short reply. 0.99. What is the ratio of the Total Labor Force (in %) in OECD members in 2009 to that in 2013?
Provide a succinct answer. 0.99. What is the ratio of the Total Labor Force (in %) of South Asia in 2009 to that in 2013?
Your answer should be very brief. 1.07. What is the ratio of the Total Labor Force (in %) of Portugal in 2009 to that in 2013?
Your response must be concise. 0.99. What is the ratio of the Total Labor Force (in %) of South Asia in 2010 to that in 2011?
Offer a very short reply. 1.02. What is the ratio of the Total Labor Force (in %) of World in 2010 to that in 2011?
Ensure brevity in your answer.  1. What is the ratio of the Total Labor Force (in %) of Portugal in 2010 to that in 2011?
Make the answer very short. 1. What is the ratio of the Total Labor Force (in %) in OECD members in 2010 to that in 2012?
Provide a succinct answer. 0.99. What is the ratio of the Total Labor Force (in %) of South Asia in 2010 to that in 2012?
Make the answer very short. 1.04. What is the ratio of the Total Labor Force (in %) of Portugal in 2010 to that in 2012?
Ensure brevity in your answer.  1. What is the ratio of the Total Labor Force (in %) of OECD members in 2010 to that in 2013?
Provide a succinct answer. 0.99. What is the ratio of the Total Labor Force (in %) of South Asia in 2010 to that in 2013?
Offer a very short reply. 1.04. What is the ratio of the Total Labor Force (in %) of World in 2010 to that in 2013?
Your answer should be compact. 1. What is the ratio of the Total Labor Force (in %) in Portugal in 2010 to that in 2013?
Your answer should be very brief. 1. What is the ratio of the Total Labor Force (in %) in South Asia in 2011 to that in 2012?
Provide a short and direct response. 1.02. What is the ratio of the Total Labor Force (in %) in World in 2011 to that in 2012?
Offer a terse response. 1. What is the ratio of the Total Labor Force (in %) in OECD members in 2011 to that in 2013?
Give a very brief answer. 0.99. What is the ratio of the Total Labor Force (in %) in South Asia in 2011 to that in 2013?
Keep it short and to the point. 1.02. What is the ratio of the Total Labor Force (in %) in World in 2011 to that in 2013?
Your response must be concise. 1. What is the ratio of the Total Labor Force (in %) in World in 2012 to that in 2013?
Your answer should be very brief. 1. What is the ratio of the Total Labor Force (in %) in Portugal in 2012 to that in 2013?
Offer a very short reply. 1. What is the difference between the highest and the second highest Total Labor Force (in %) in OECD members?
Provide a succinct answer. 0.14. What is the difference between the highest and the second highest Total Labor Force (in %) in South Asia?
Ensure brevity in your answer.  1.22. What is the difference between the highest and the second highest Total Labor Force (in %) in World?
Keep it short and to the point. 0.35. What is the difference between the highest and the second highest Total Labor Force (in %) of Portugal?
Give a very brief answer. 0. What is the difference between the highest and the lowest Total Labor Force (in %) of OECD members?
Make the answer very short. 1.51. What is the difference between the highest and the lowest Total Labor Force (in %) of South Asia?
Your response must be concise. 4.67. What is the difference between the highest and the lowest Total Labor Force (in %) of World?
Your answer should be compact. 1.1. What is the difference between the highest and the lowest Total Labor Force (in %) of Portugal?
Offer a terse response. 1.2. 